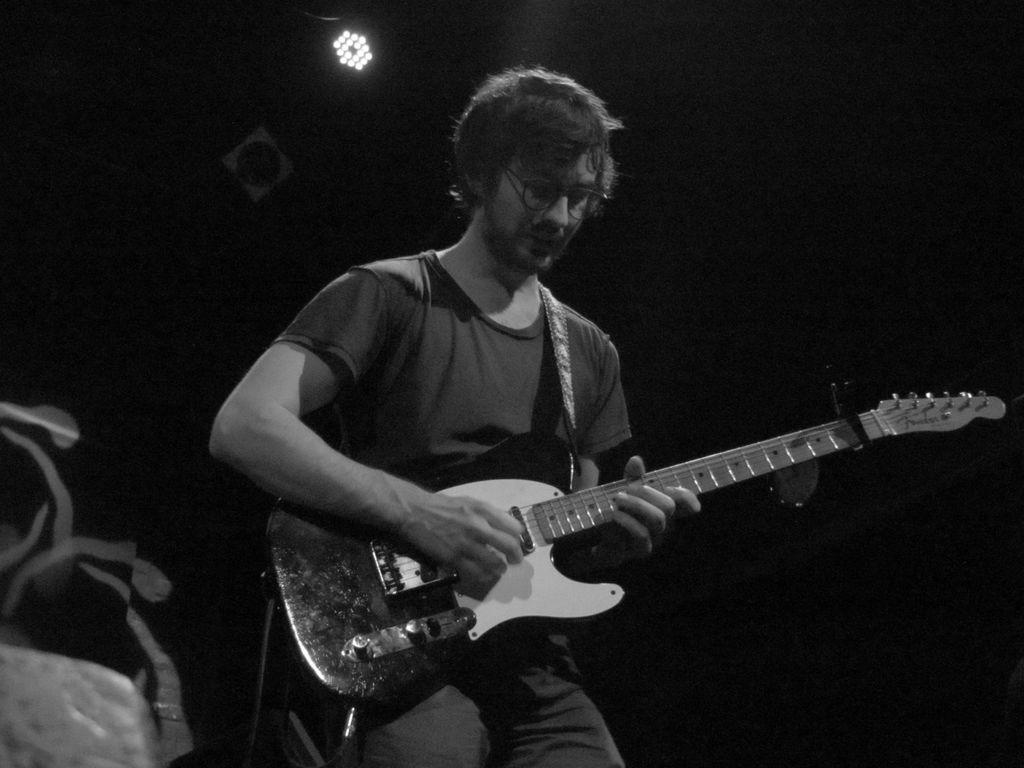Who is present in the image? There is a man in the image. What is the man holding in the image? The man is holding a guitar. What can be seen in the background of the image? There is a curtain and light in the background of the image. What is the man's opinion on the hill in the image? There is no hill present in the image, so it is not possible to determine the man's opinion on it. 